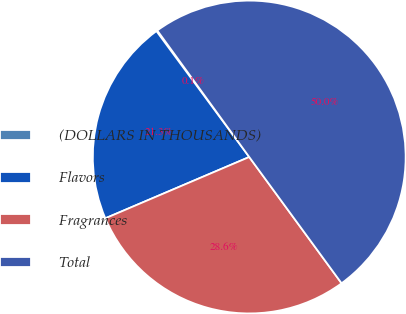Convert chart to OTSL. <chart><loc_0><loc_0><loc_500><loc_500><pie_chart><fcel>(DOLLARS IN THOUSANDS)<fcel>Flavors<fcel>Fragrances<fcel>Total<nl><fcel>0.11%<fcel>21.3%<fcel>28.64%<fcel>49.95%<nl></chart> 